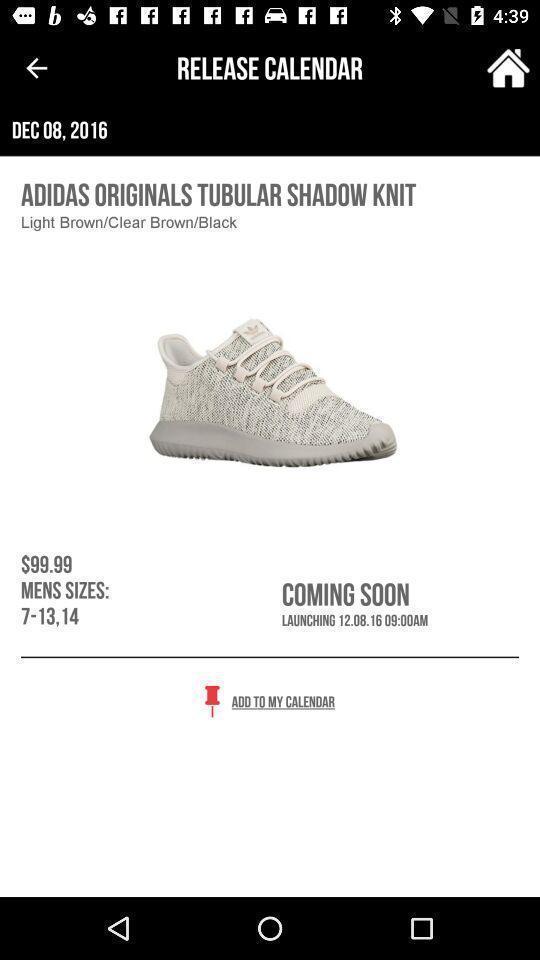Describe the content in this image. Screen displaying the price and size of a shoes. 